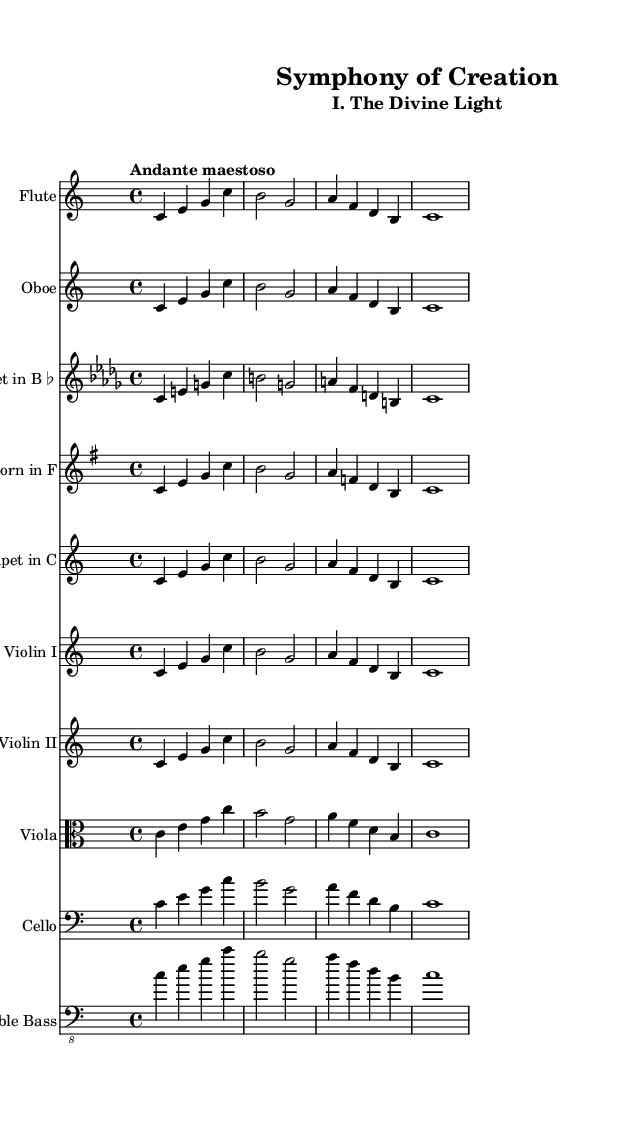What is the key signature of this music? The key signature is indicated at the beginning of the sheet music, showing that it is in C major, which has no sharps or flats.
Answer: C major What is the time signature of this music? The time signature is displayed at the beginning of the sheet music in the form of a fraction, showing that it is 4/4, which means there are four beats in each measure.
Answer: 4/4 What is the tempo of this music? The tempo instructions are written above the staff, indicating that the piece should be played "Andante maestoso," which refers to a moderately slow and dignified pace.
Answer: Andante maestoso How many instruments are featured in this symphony? By counting the staves listed in the score, there are ten distinct instruments shown, each represented by its own staff.
Answer: 10 Identify the instrument that has a clef marked as "alto." The viola staff has an alto clef, which is used for instruments that play in a higher register but lower than the treble clef.
Answer: Viola What is the first note of the main theme? The first note appears at the beginning of the main theme for the instruments and is a "C" note, which is indicated in the notation.
Answer: C What section of this symphony is indicated by the subtitle? The subtitle states "I. The Divine Light," which signifies that this part of the symphony is the first movement.
Answer: I. The Divine Light 